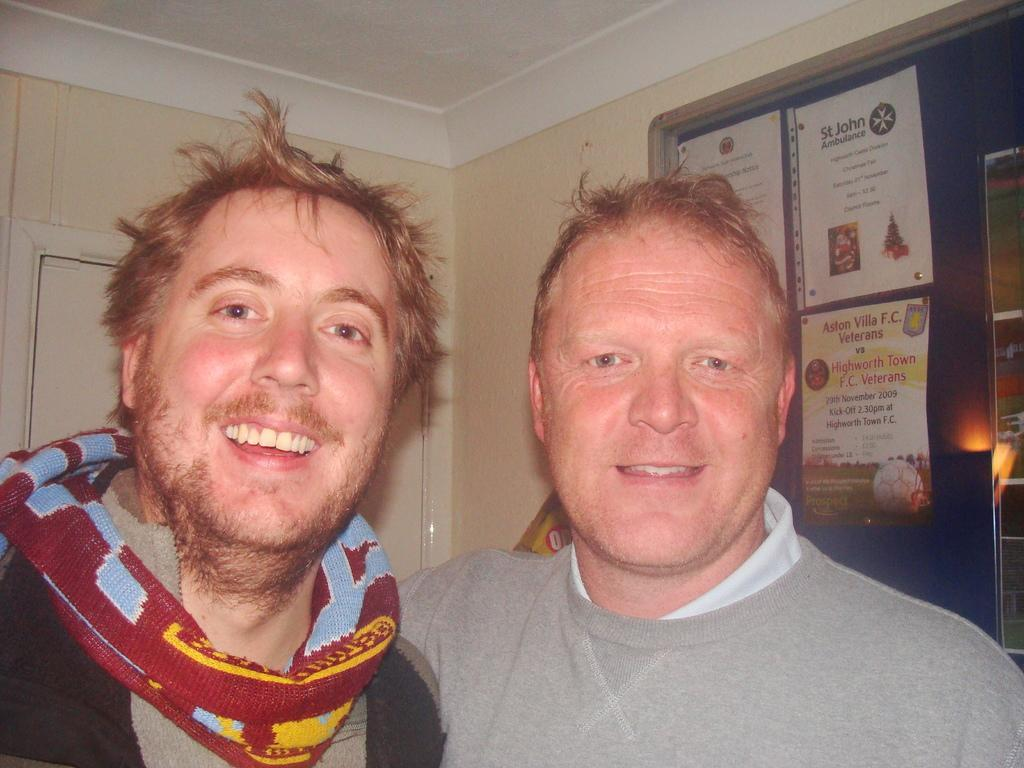How many people are in the image? There are two people standing in the image. What is the facial expression of the people in the image? The people are smiling. What can be seen on the right side of the image? There is a board with written text on the right side of the image. Can you tell me how many dogs are part of the flock in the image? There are no dogs or flock present in the image; it features two people standing and smiling. What type of shake is being offered to the people in the image? There is no shake present in the image; it only shows two people standing and smiling, along with a board with written text on the right side. 